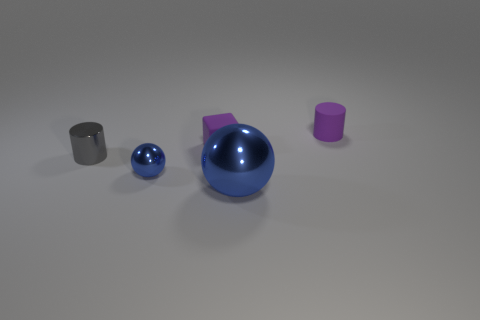Add 3 large things. How many objects exist? 8 Subtract all gray cylinders. How many cylinders are left? 1 Subtract 1 cubes. How many cubes are left? 0 Subtract all brown cubes. Subtract all green cylinders. How many cubes are left? 1 Subtract all green cylinders. How many yellow cubes are left? 0 Subtract all large green rubber cubes. Subtract all small blue metal spheres. How many objects are left? 4 Add 3 blue spheres. How many blue spheres are left? 5 Add 2 small balls. How many small balls exist? 3 Subtract 0 yellow balls. How many objects are left? 5 Subtract all cylinders. How many objects are left? 3 